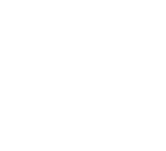<formula> <loc_0><loc_0><loc_500><loc_500>\begin{smallmatrix} 2 & 0 & 1 & 1 & 0 & 0 & 1 \\ 0 & 2 & 1 & 0 & 1 & 0 & 0 \\ 1 & 1 & 3 & 1 & 1 & 1 & 0 \\ 1 & 0 & 1 & 3 & 0 & 1 & 1 \\ 0 & 1 & 1 & 0 & 3 & 1 & 1 \\ 0 & 0 & 1 & 1 & 1 & 3 & 0 \\ 1 & 0 & 0 & 1 & 1 & 0 & 3 \end{smallmatrix}</formula> 